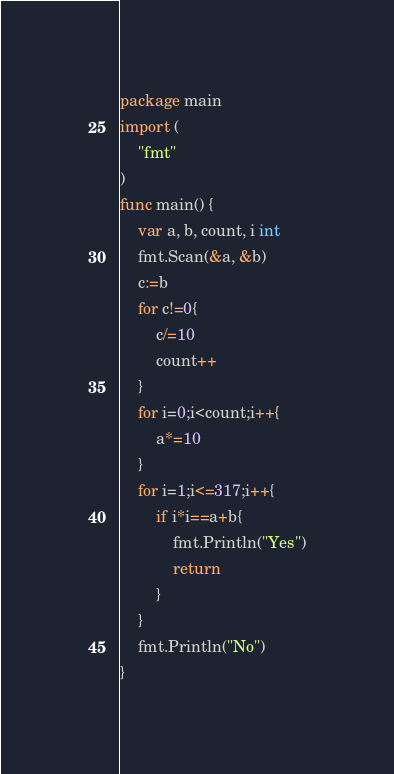<code> <loc_0><loc_0><loc_500><loc_500><_Go_>package main
import (
	"fmt"
)
func main() {
	var a, b, count, i int
	fmt.Scan(&a, &b)
	c:=b
	for c!=0{
		c/=10
		count++
	}
	for i=0;i<count;i++{
		a*=10
	}
	for i=1;i<=317;i++{
		if i*i==a+b{
			fmt.Println("Yes")
			return
		}
	}
	fmt.Println("No")
}
</code> 